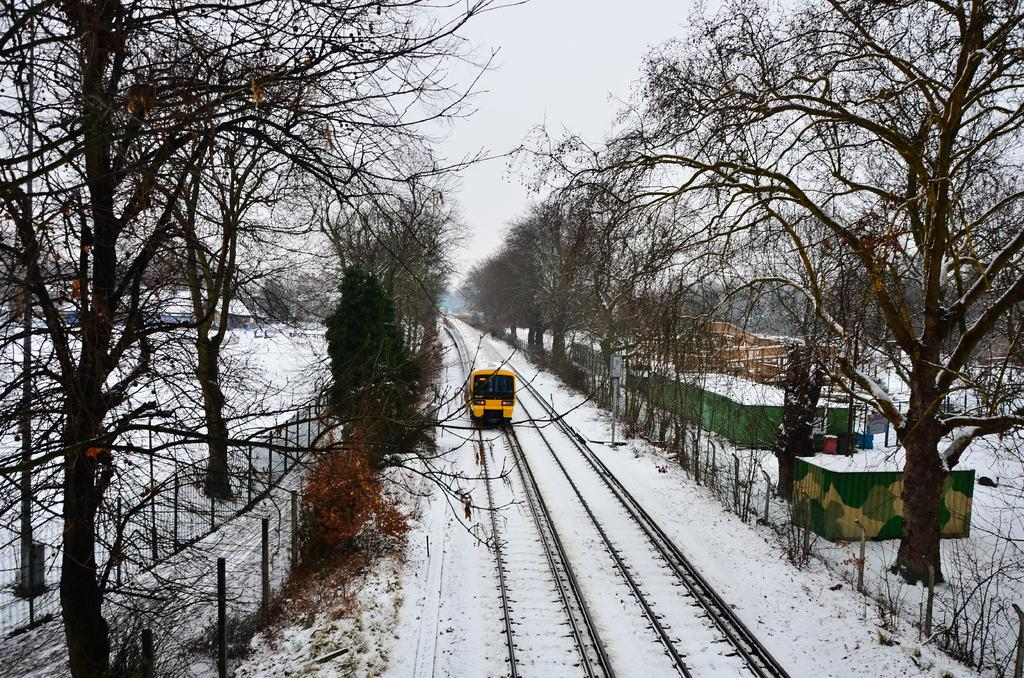What is the main subject of the image? The main subject of the image is a locomotive on the track. What can be seen in the background of the image? There is a group of trees in the image, and the sky is visible and appears cloudy. What is covering the ground in the image? The ground appears to be covered in snow. Are there any structures or objects near the locomotive? Yes, there is a fence and some poles in the image. What else can be seen in the image? There are houses in the image. How many cans of star-shaped air are visible in the image? There are no cans or star-shaped air present in the image. 